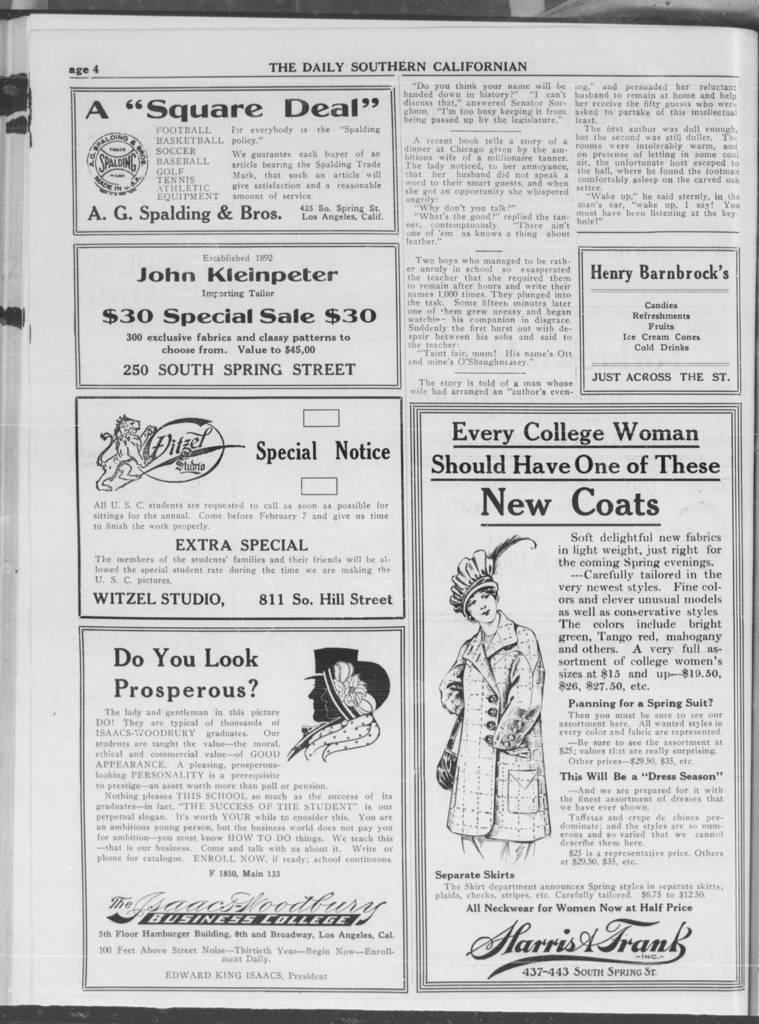What is the main subject of the image? The main subject of the image is a page of a book. What type of content can be found on the page? The page contains both text and images. What color are the lips of the person reading the book in the image? There is no person present in the image, and therefore no lips to observe. 